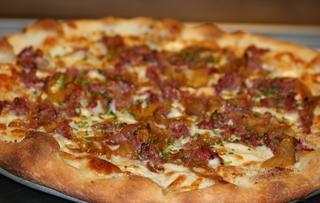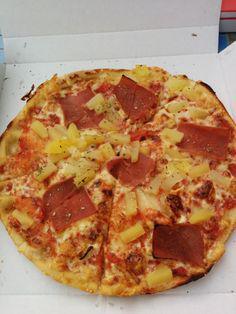The first image is the image on the left, the second image is the image on the right. Analyze the images presented: Is the assertion "The pizzas in both images are not circles, but are shaped like rectangles instead." valid? Answer yes or no. No. The first image is the image on the left, the second image is the image on the right. Evaluate the accuracy of this statement regarding the images: "No image shows a round pizza or triangular slice, and one image shows less than a complete rectangular pizza.". Is it true? Answer yes or no. No. 